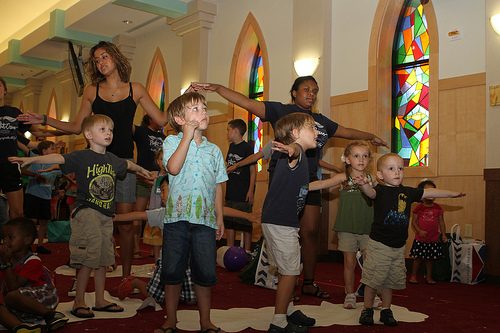<image>
Is the boy one next to the boy two? No. The boy one is not positioned next to the boy two. They are located in different areas of the scene. 